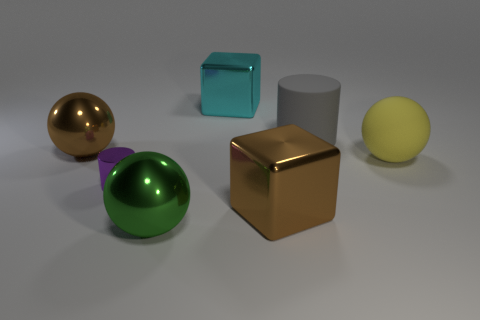Subtract all metal balls. How many balls are left? 1 Subtract all gray cylinders. How many cylinders are left? 1 Add 1 tiny cylinders. How many objects exist? 8 Subtract 1 cylinders. How many cylinders are left? 1 Subtract all balls. How many objects are left? 4 Add 3 small metallic spheres. How many small metallic spheres exist? 3 Subtract 1 green balls. How many objects are left? 6 Subtract all cyan blocks. Subtract all red cylinders. How many blocks are left? 1 Subtract all big purple balls. Subtract all big green metal balls. How many objects are left? 6 Add 7 balls. How many balls are left? 10 